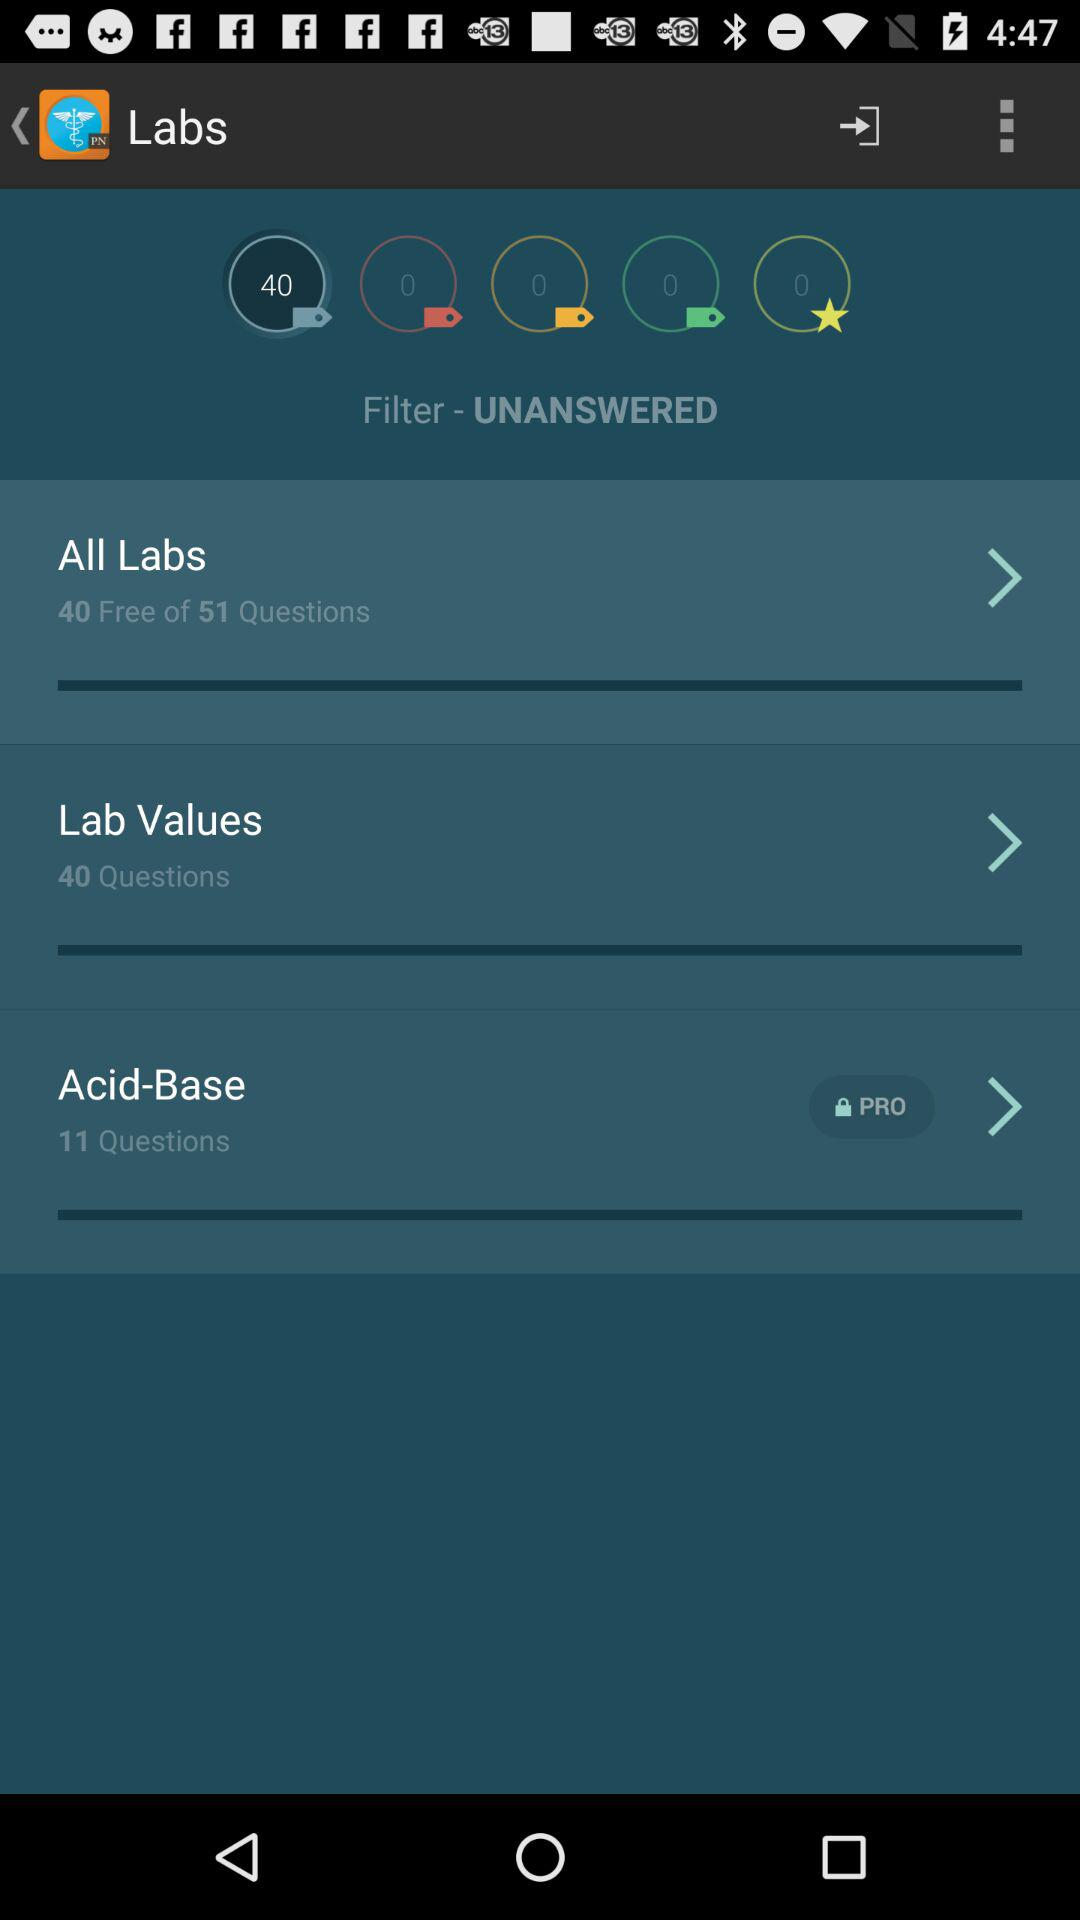How many questions can I answer for free?
Answer the question using a single word or phrase. 40 